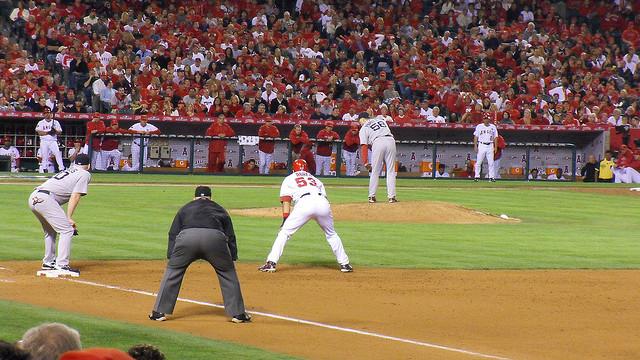What sport are they playing?
Short answer required. Baseball. What number does the pitcher have?
Keep it brief. 50. What is the man in gray pant's job?
Be succinct. Umpire. 